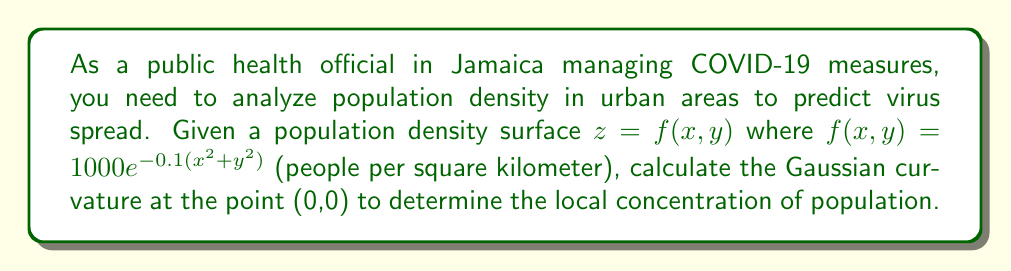Solve this math problem. To calculate the Gaussian curvature of the population density surface, we'll follow these steps:

1) The Gaussian curvature K is given by:
   $$K = \frac{f_{xx}f_{yy} - f_{xy}^2}{(1 + f_x^2 + f_y^2)^2}$$
   where subscripts denote partial derivatives.

2) Calculate the partial derivatives:
   $$f_x = -200xe^{-0.1(x^2+y^2)}$$
   $$f_y = -200ye^{-0.1(x^2+y^2)}$$
   $$f_{xx} = (-200 + 40x^2)e^{-0.1(x^2+y^2)}$$
   $$f_{yy} = (-200 + 40y^2)e^{-0.1(x^2+y^2)}$$
   $$f_{xy} = 40xye^{-0.1(x^2+y^2)}$$

3) Evaluate these at the point (0,0):
   $$f_x(0,0) = f_y(0,0) = 0$$
   $$f_{xx}(0,0) = f_{yy}(0,0) = -200$$
   $$f_{xy}(0,0) = 0$$

4) Substitute into the Gaussian curvature formula:
   $$K = \frac{(-200)(-200) - 0^2}{(1 + 0^2 + 0^2)^2} = \frac{40000}{1} = 40000$$

This high positive value indicates a strong peak in population density at (0,0), which could be a potential hotspot for COVID-19 transmission.
Answer: $40000$ km^-2 